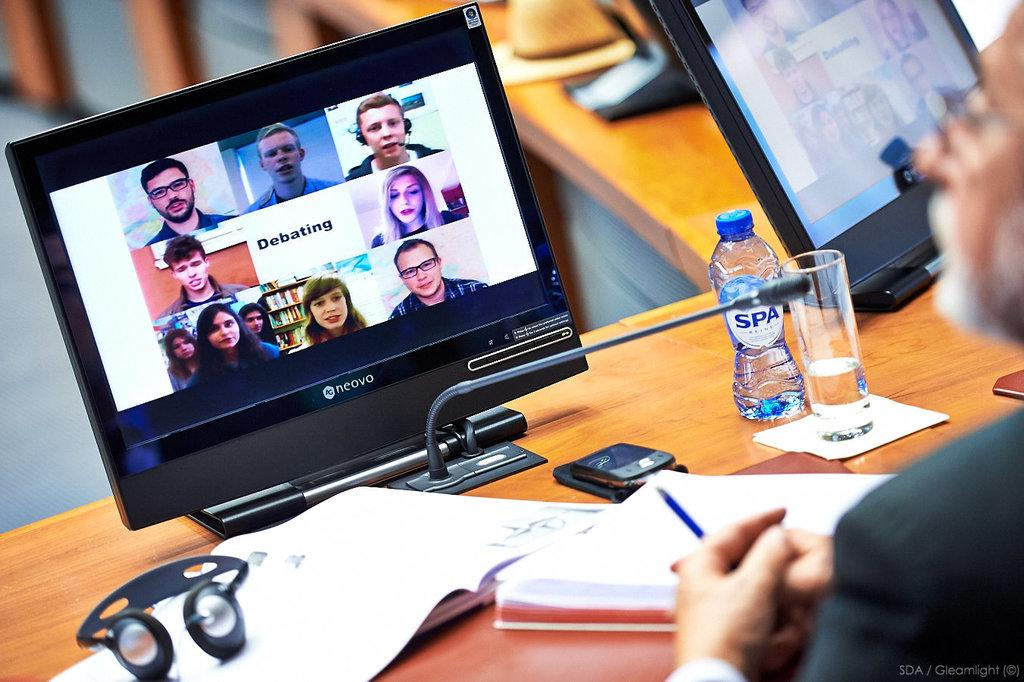<image>
Create a compact narrative representing the image presented. A man is working at a computer desk with a screen that says Debating. 